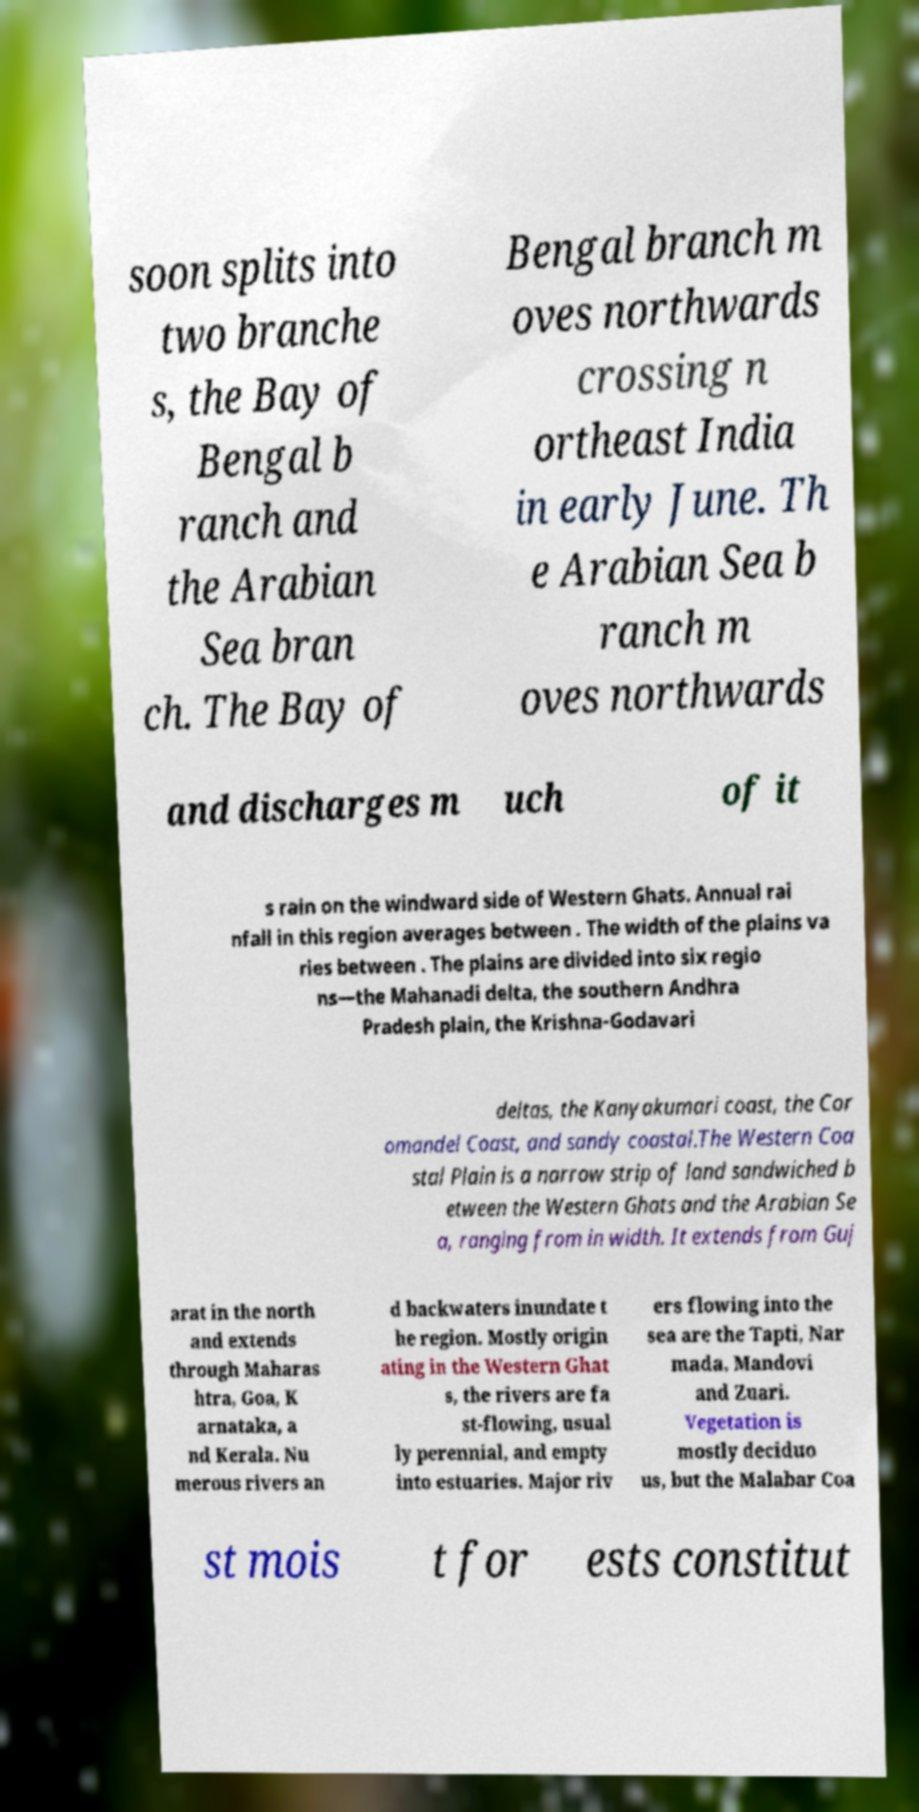Could you assist in decoding the text presented in this image and type it out clearly? soon splits into two branche s, the Bay of Bengal b ranch and the Arabian Sea bran ch. The Bay of Bengal branch m oves northwards crossing n ortheast India in early June. Th e Arabian Sea b ranch m oves northwards and discharges m uch of it s rain on the windward side of Western Ghats. Annual rai nfall in this region averages between . The width of the plains va ries between . The plains are divided into six regio ns—the Mahanadi delta, the southern Andhra Pradesh plain, the Krishna-Godavari deltas, the Kanyakumari coast, the Cor omandel Coast, and sandy coastal.The Western Coa stal Plain is a narrow strip of land sandwiched b etween the Western Ghats and the Arabian Se a, ranging from in width. It extends from Guj arat in the north and extends through Maharas htra, Goa, K arnataka, a nd Kerala. Nu merous rivers an d backwaters inundate t he region. Mostly origin ating in the Western Ghat s, the rivers are fa st-flowing, usual ly perennial, and empty into estuaries. Major riv ers flowing into the sea are the Tapti, Nar mada, Mandovi and Zuari. Vegetation is mostly deciduo us, but the Malabar Coa st mois t for ests constitut 